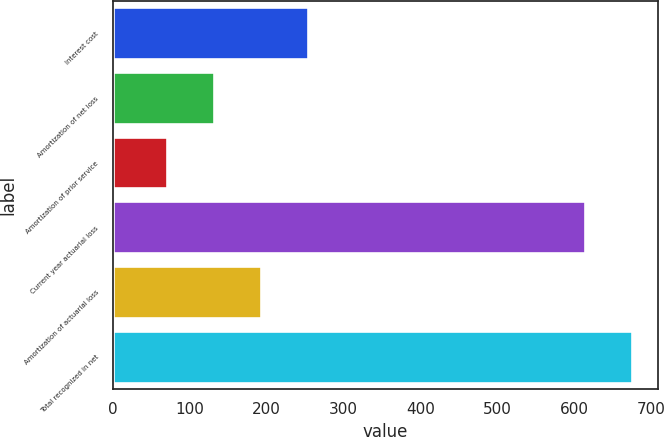Convert chart to OTSL. <chart><loc_0><loc_0><loc_500><loc_500><bar_chart><fcel>Interest cost<fcel>Amortization of net loss<fcel>Amortization of prior service<fcel>Current year actuarial loss<fcel>Amortization of actuarial loss<fcel>Total recognized in net<nl><fcel>254<fcel>132<fcel>71<fcel>615<fcel>193<fcel>676<nl></chart> 